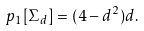Convert formula to latex. <formula><loc_0><loc_0><loc_500><loc_500>p _ { 1 } [ \Sigma _ { d } ] = ( 4 - d ^ { 2 } ) d .</formula> 